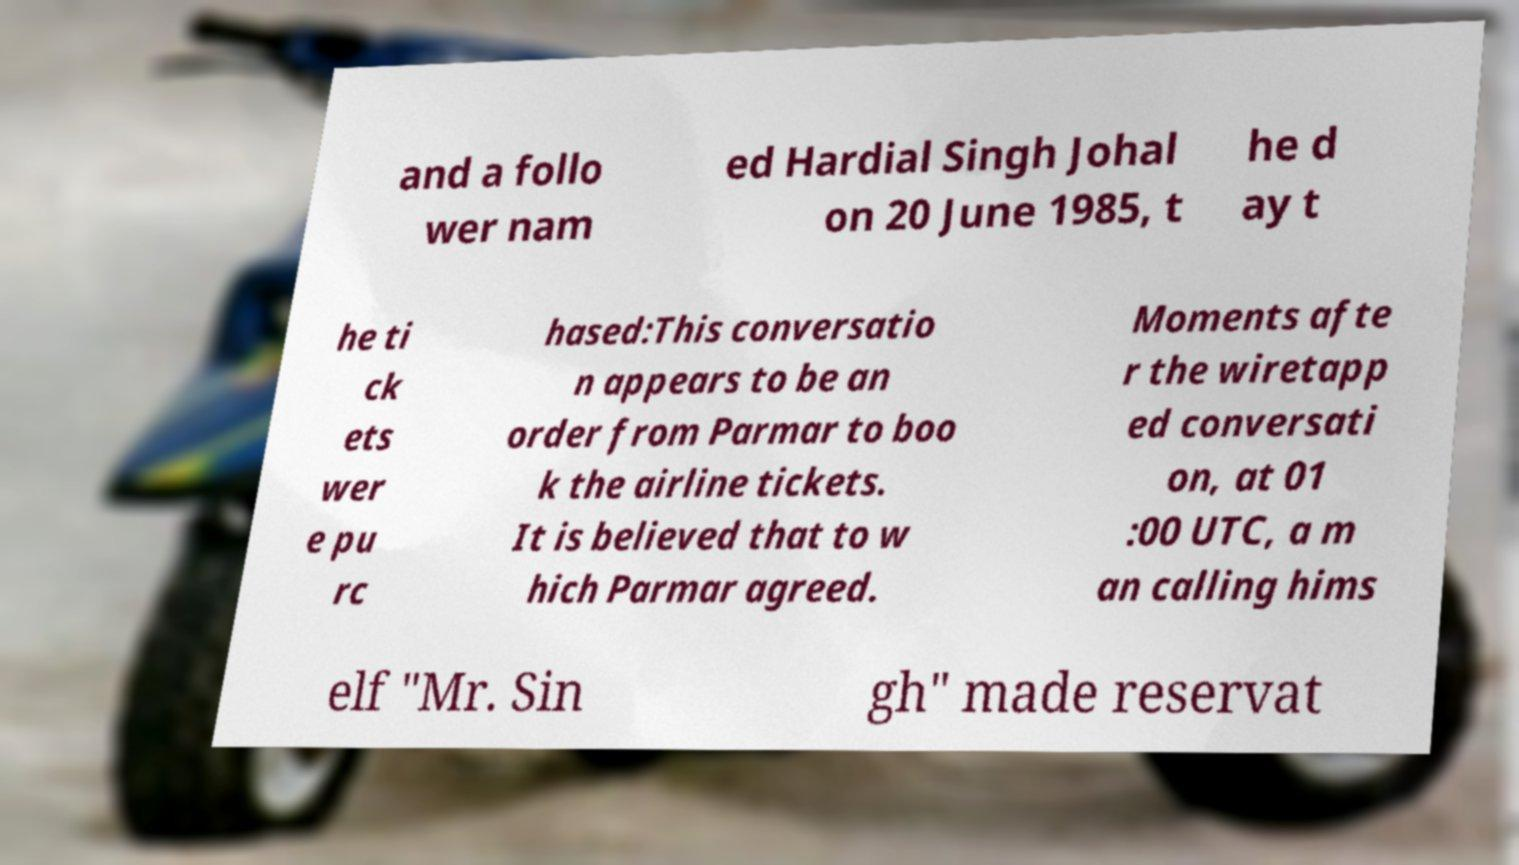Can you read and provide the text displayed in the image?This photo seems to have some interesting text. Can you extract and type it out for me? and a follo wer nam ed Hardial Singh Johal on 20 June 1985, t he d ay t he ti ck ets wer e pu rc hased:This conversatio n appears to be an order from Parmar to boo k the airline tickets. It is believed that to w hich Parmar agreed. Moments afte r the wiretapp ed conversati on, at 01 :00 UTC, a m an calling hims elf "Mr. Sin gh" made reservat 